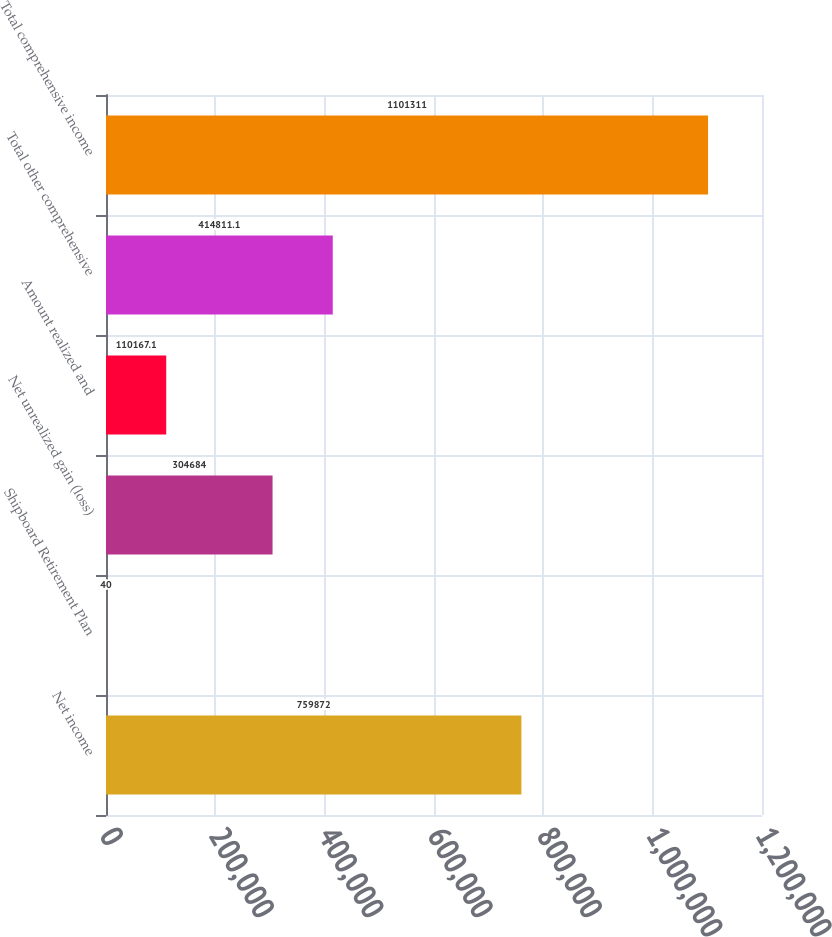Convert chart to OTSL. <chart><loc_0><loc_0><loc_500><loc_500><bar_chart><fcel>Net income<fcel>Shipboard Retirement Plan<fcel>Net unrealized gain (loss)<fcel>Amount realized and<fcel>Total other comprehensive<fcel>Total comprehensive income<nl><fcel>759872<fcel>40<fcel>304684<fcel>110167<fcel>414811<fcel>1.10131e+06<nl></chart> 